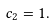<formula> <loc_0><loc_0><loc_500><loc_500>c _ { 2 } = 1 .</formula> 